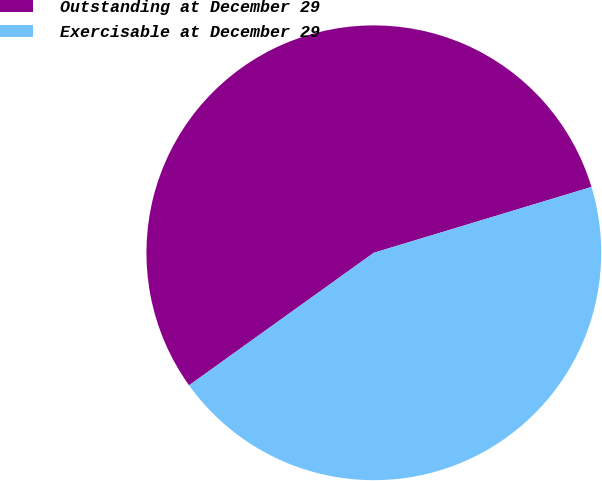Convert chart. <chart><loc_0><loc_0><loc_500><loc_500><pie_chart><fcel>Outstanding at December 29<fcel>Exercisable at December 29<nl><fcel>55.23%<fcel>44.77%<nl></chart> 